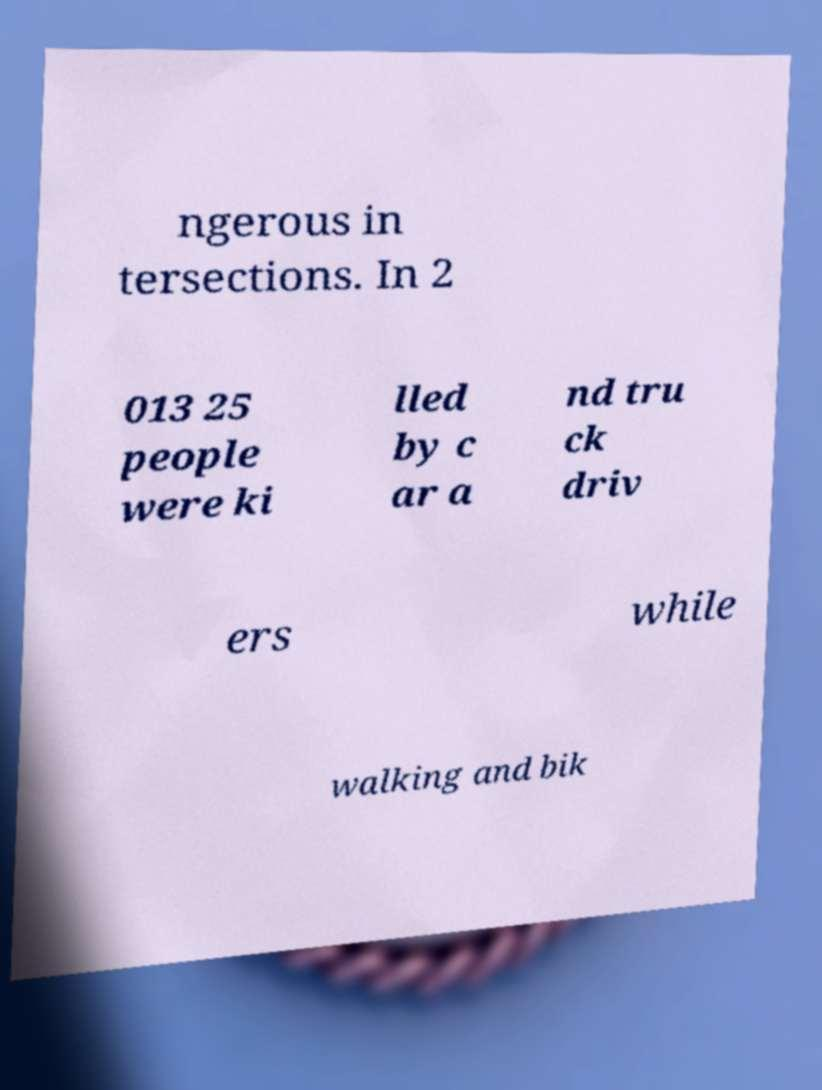For documentation purposes, I need the text within this image transcribed. Could you provide that? ngerous in tersections. In 2 013 25 people were ki lled by c ar a nd tru ck driv ers while walking and bik 